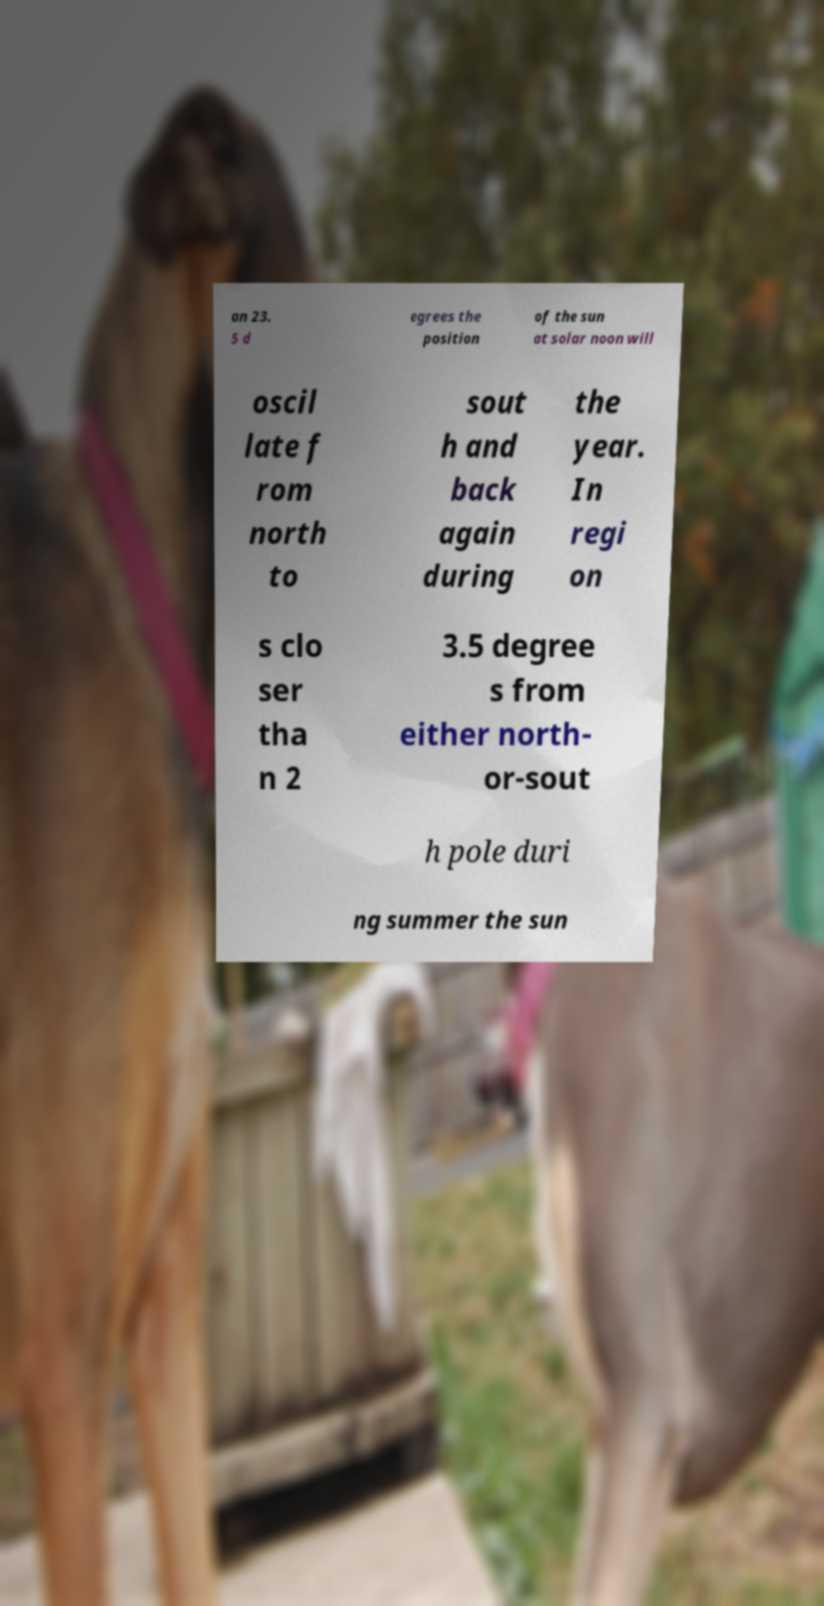Can you read and provide the text displayed in the image?This photo seems to have some interesting text. Can you extract and type it out for me? an 23. 5 d egrees the position of the sun at solar noon will oscil late f rom north to sout h and back again during the year. In regi on s clo ser tha n 2 3.5 degree s from either north- or-sout h pole duri ng summer the sun 